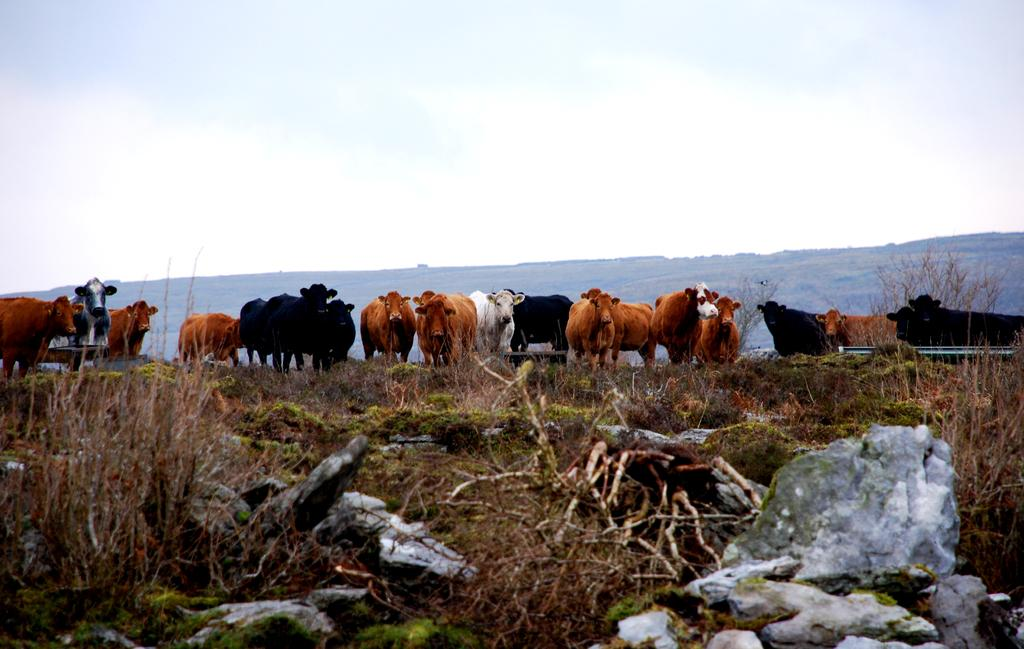What type of natural elements can be seen in the image? There are branches and rocks visible in the image. What type of animals are present in the image? There is a herd of animals in the image. What can be seen in the background of the image? There is a hill and the sky visible in the background of the image. What type of patch can be seen on the animal's back in the image? There are no patches visible on the animals' backs in the image. How does the herd of animals start their journey in the image? The image does not depict the animals starting their journey; it simply shows them in a herd. 